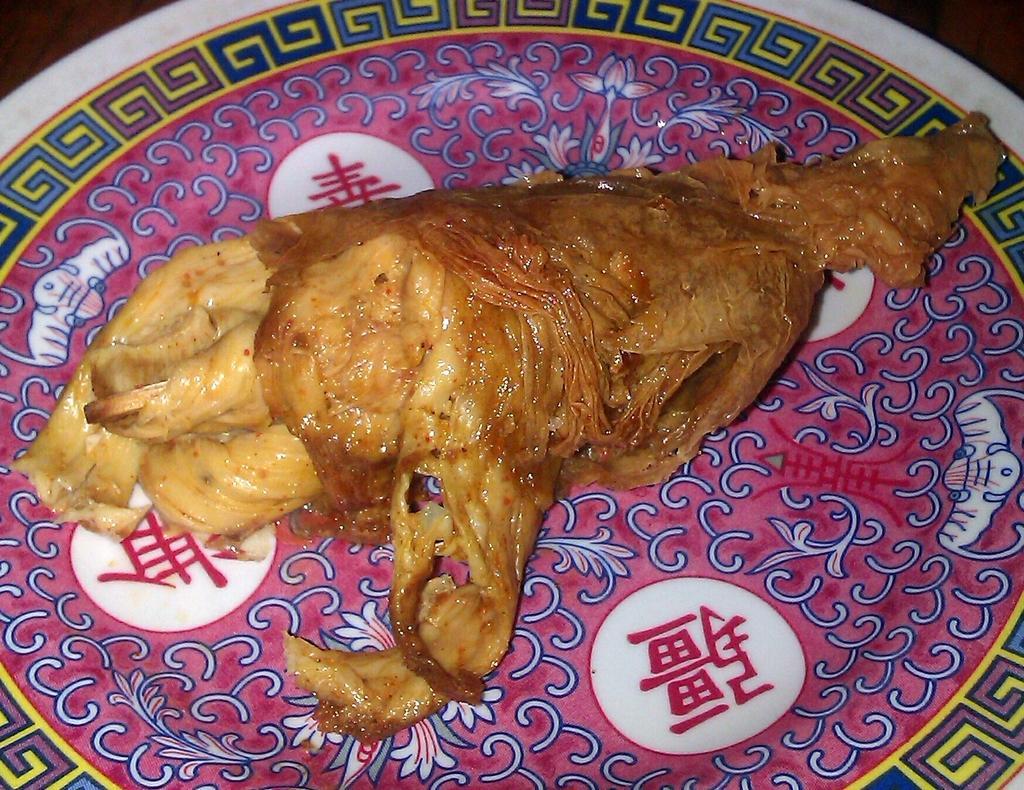Please provide a concise description of this image. In the center of this picture we can see a platter containing some food item. 